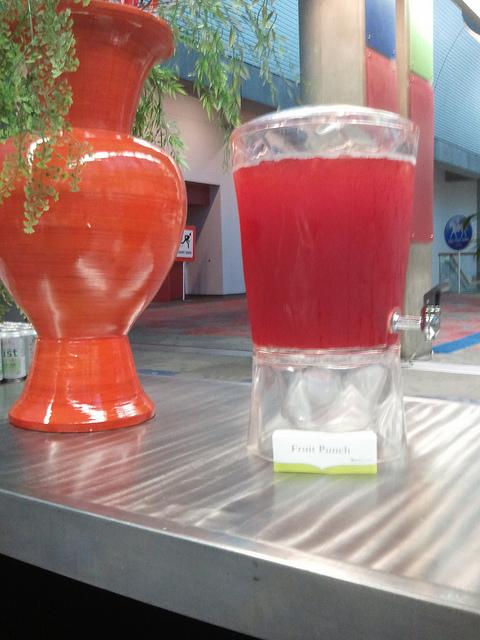What type of station is this? beverage 